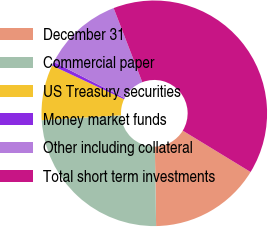<chart> <loc_0><loc_0><loc_500><loc_500><pie_chart><fcel>December 31<fcel>Commercial paper<fcel>US Treasury securities<fcel>Money market funds<fcel>Other including collateral<fcel>Total short term investments<nl><fcel>16.03%<fcel>24.28%<fcel>7.93%<fcel>0.57%<fcel>11.61%<fcel>39.59%<nl></chart> 